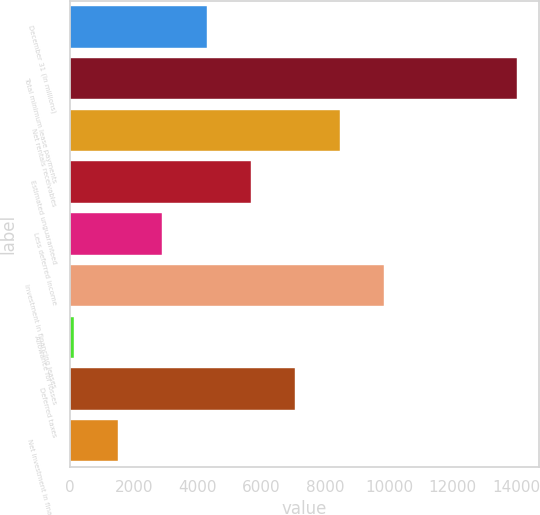Convert chart. <chart><loc_0><loc_0><loc_500><loc_500><bar_chart><fcel>December 31 (In millions)<fcel>Total minimum lease payments<fcel>Net rentals receivables<fcel>Estimated unguaranteed<fcel>Less deferred income<fcel>Investment in financing leases<fcel>Allowance for losses<fcel>Deferred taxes<fcel>Net investment in financing<nl><fcel>4287.6<fcel>14012<fcel>8455.2<fcel>5676.8<fcel>2898.4<fcel>9844.4<fcel>120<fcel>7066<fcel>1509.2<nl></chart> 